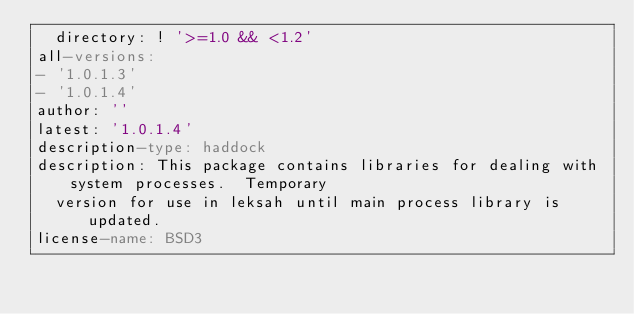<code> <loc_0><loc_0><loc_500><loc_500><_YAML_>  directory: ! '>=1.0 && <1.2'
all-versions:
- '1.0.1.3'
- '1.0.1.4'
author: ''
latest: '1.0.1.4'
description-type: haddock
description: This package contains libraries for dealing with system processes.  Temporary
  version for use in leksah until main process library is updated.
license-name: BSD3
</code> 